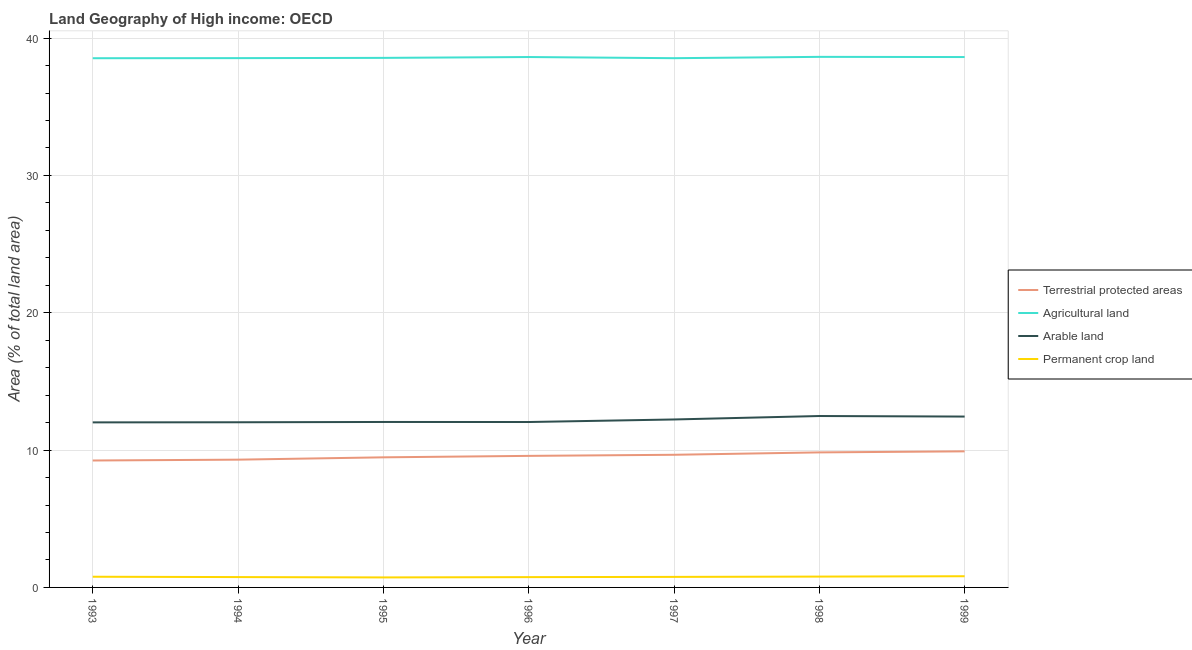How many different coloured lines are there?
Provide a succinct answer. 4. What is the percentage of area under arable land in 1993?
Your answer should be compact. 12.02. Across all years, what is the maximum percentage of area under permanent crop land?
Ensure brevity in your answer.  0.81. Across all years, what is the minimum percentage of area under arable land?
Provide a short and direct response. 12.02. In which year was the percentage of area under arable land maximum?
Provide a succinct answer. 1998. In which year was the percentage of area under arable land minimum?
Ensure brevity in your answer.  1993. What is the total percentage of land under terrestrial protection in the graph?
Provide a short and direct response. 67. What is the difference between the percentage of area under permanent crop land in 1993 and that in 1995?
Keep it short and to the point. 0.05. What is the difference between the percentage of area under arable land in 1998 and the percentage of land under terrestrial protection in 1995?
Ensure brevity in your answer.  3.01. What is the average percentage of area under permanent crop land per year?
Offer a very short reply. 0.77. In the year 1998, what is the difference between the percentage of area under arable land and percentage of land under terrestrial protection?
Offer a very short reply. 2.65. In how many years, is the percentage of land under terrestrial protection greater than 28 %?
Offer a very short reply. 0. What is the ratio of the percentage of area under arable land in 1997 to that in 1998?
Offer a very short reply. 0.98. Is the difference between the percentage of area under permanent crop land in 1994 and 1995 greater than the difference between the percentage of land under terrestrial protection in 1994 and 1995?
Make the answer very short. Yes. What is the difference between the highest and the second highest percentage of area under agricultural land?
Ensure brevity in your answer.  0.01. What is the difference between the highest and the lowest percentage of land under terrestrial protection?
Offer a very short reply. 0.67. In how many years, is the percentage of area under permanent crop land greater than the average percentage of area under permanent crop land taken over all years?
Offer a terse response. 3. Is it the case that in every year, the sum of the percentage of land under terrestrial protection and percentage of area under arable land is greater than the sum of percentage of area under permanent crop land and percentage of area under agricultural land?
Offer a terse response. Yes. Is it the case that in every year, the sum of the percentage of land under terrestrial protection and percentage of area under agricultural land is greater than the percentage of area under arable land?
Give a very brief answer. Yes. Does the percentage of area under agricultural land monotonically increase over the years?
Your answer should be very brief. No. How many lines are there?
Offer a terse response. 4. How many years are there in the graph?
Provide a short and direct response. 7. Are the values on the major ticks of Y-axis written in scientific E-notation?
Keep it short and to the point. No. Does the graph contain grids?
Make the answer very short. Yes. Where does the legend appear in the graph?
Provide a short and direct response. Center right. What is the title of the graph?
Give a very brief answer. Land Geography of High income: OECD. What is the label or title of the Y-axis?
Your answer should be very brief. Area (% of total land area). What is the Area (% of total land area) in Terrestrial protected areas in 1993?
Your response must be concise. 9.24. What is the Area (% of total land area) in Agricultural land in 1993?
Offer a very short reply. 38.53. What is the Area (% of total land area) of Arable land in 1993?
Make the answer very short. 12.02. What is the Area (% of total land area) of Permanent crop land in 1993?
Your response must be concise. 0.78. What is the Area (% of total land area) in Terrestrial protected areas in 1994?
Your answer should be very brief. 9.3. What is the Area (% of total land area) in Agricultural land in 1994?
Offer a terse response. 38.54. What is the Area (% of total land area) in Arable land in 1994?
Give a very brief answer. 12.03. What is the Area (% of total land area) of Permanent crop land in 1994?
Make the answer very short. 0.75. What is the Area (% of total land area) in Terrestrial protected areas in 1995?
Your response must be concise. 9.47. What is the Area (% of total land area) in Agricultural land in 1995?
Offer a very short reply. 38.56. What is the Area (% of total land area) in Arable land in 1995?
Ensure brevity in your answer.  12.05. What is the Area (% of total land area) in Permanent crop land in 1995?
Keep it short and to the point. 0.73. What is the Area (% of total land area) of Terrestrial protected areas in 1996?
Ensure brevity in your answer.  9.58. What is the Area (% of total land area) of Agricultural land in 1996?
Your answer should be very brief. 38.62. What is the Area (% of total land area) in Arable land in 1996?
Provide a succinct answer. 12.04. What is the Area (% of total land area) of Permanent crop land in 1996?
Give a very brief answer. 0.75. What is the Area (% of total land area) in Terrestrial protected areas in 1997?
Ensure brevity in your answer.  9.66. What is the Area (% of total land area) in Agricultural land in 1997?
Make the answer very short. 38.54. What is the Area (% of total land area) in Arable land in 1997?
Offer a very short reply. 12.23. What is the Area (% of total land area) of Permanent crop land in 1997?
Make the answer very short. 0.77. What is the Area (% of total land area) of Terrestrial protected areas in 1998?
Your answer should be very brief. 9.83. What is the Area (% of total land area) in Agricultural land in 1998?
Ensure brevity in your answer.  38.63. What is the Area (% of total land area) in Arable land in 1998?
Your answer should be compact. 12.48. What is the Area (% of total land area) of Permanent crop land in 1998?
Your answer should be compact. 0.79. What is the Area (% of total land area) of Terrestrial protected areas in 1999?
Ensure brevity in your answer.  9.91. What is the Area (% of total land area) of Agricultural land in 1999?
Keep it short and to the point. 38.62. What is the Area (% of total land area) in Arable land in 1999?
Give a very brief answer. 12.44. What is the Area (% of total land area) in Permanent crop land in 1999?
Your response must be concise. 0.81. Across all years, what is the maximum Area (% of total land area) of Terrestrial protected areas?
Give a very brief answer. 9.91. Across all years, what is the maximum Area (% of total land area) of Agricultural land?
Provide a short and direct response. 38.63. Across all years, what is the maximum Area (% of total land area) of Arable land?
Offer a terse response. 12.48. Across all years, what is the maximum Area (% of total land area) in Permanent crop land?
Offer a very short reply. 0.81. Across all years, what is the minimum Area (% of total land area) in Terrestrial protected areas?
Your answer should be very brief. 9.24. Across all years, what is the minimum Area (% of total land area) of Agricultural land?
Give a very brief answer. 38.53. Across all years, what is the minimum Area (% of total land area) of Arable land?
Keep it short and to the point. 12.02. Across all years, what is the minimum Area (% of total land area) of Permanent crop land?
Offer a terse response. 0.73. What is the total Area (% of total land area) of Terrestrial protected areas in the graph?
Give a very brief answer. 67. What is the total Area (% of total land area) of Agricultural land in the graph?
Offer a terse response. 270.04. What is the total Area (% of total land area) of Arable land in the graph?
Ensure brevity in your answer.  85.29. What is the total Area (% of total land area) in Permanent crop land in the graph?
Offer a very short reply. 5.38. What is the difference between the Area (% of total land area) in Terrestrial protected areas in 1993 and that in 1994?
Your answer should be very brief. -0.06. What is the difference between the Area (% of total land area) of Agricultural land in 1993 and that in 1994?
Your answer should be compact. -0.01. What is the difference between the Area (% of total land area) in Arable land in 1993 and that in 1994?
Offer a terse response. -0.01. What is the difference between the Area (% of total land area) of Permanent crop land in 1993 and that in 1994?
Provide a short and direct response. 0.03. What is the difference between the Area (% of total land area) in Terrestrial protected areas in 1993 and that in 1995?
Your answer should be compact. -0.23. What is the difference between the Area (% of total land area) of Agricultural land in 1993 and that in 1995?
Make the answer very short. -0.02. What is the difference between the Area (% of total land area) of Arable land in 1993 and that in 1995?
Your answer should be very brief. -0.03. What is the difference between the Area (% of total land area) of Permanent crop land in 1993 and that in 1995?
Offer a very short reply. 0.05. What is the difference between the Area (% of total land area) of Terrestrial protected areas in 1993 and that in 1996?
Give a very brief answer. -0.34. What is the difference between the Area (% of total land area) in Agricultural land in 1993 and that in 1996?
Your response must be concise. -0.09. What is the difference between the Area (% of total land area) in Arable land in 1993 and that in 1996?
Give a very brief answer. -0.03. What is the difference between the Area (% of total land area) of Permanent crop land in 1993 and that in 1996?
Offer a very short reply. 0.03. What is the difference between the Area (% of total land area) of Terrestrial protected areas in 1993 and that in 1997?
Offer a terse response. -0.42. What is the difference between the Area (% of total land area) of Agricultural land in 1993 and that in 1997?
Provide a short and direct response. -0. What is the difference between the Area (% of total land area) in Arable land in 1993 and that in 1997?
Keep it short and to the point. -0.21. What is the difference between the Area (% of total land area) in Permanent crop land in 1993 and that in 1997?
Ensure brevity in your answer.  0.01. What is the difference between the Area (% of total land area) of Terrestrial protected areas in 1993 and that in 1998?
Provide a succinct answer. -0.59. What is the difference between the Area (% of total land area) in Agricultural land in 1993 and that in 1998?
Your answer should be compact. -0.1. What is the difference between the Area (% of total land area) in Arable land in 1993 and that in 1998?
Provide a short and direct response. -0.46. What is the difference between the Area (% of total land area) in Permanent crop land in 1993 and that in 1998?
Provide a short and direct response. -0.01. What is the difference between the Area (% of total land area) in Terrestrial protected areas in 1993 and that in 1999?
Ensure brevity in your answer.  -0.67. What is the difference between the Area (% of total land area) in Agricultural land in 1993 and that in 1999?
Make the answer very short. -0.08. What is the difference between the Area (% of total land area) in Arable land in 1993 and that in 1999?
Give a very brief answer. -0.42. What is the difference between the Area (% of total land area) in Permanent crop land in 1993 and that in 1999?
Provide a short and direct response. -0.04. What is the difference between the Area (% of total land area) in Terrestrial protected areas in 1994 and that in 1995?
Your answer should be compact. -0.17. What is the difference between the Area (% of total land area) in Agricultural land in 1994 and that in 1995?
Your response must be concise. -0.02. What is the difference between the Area (% of total land area) of Arable land in 1994 and that in 1995?
Provide a short and direct response. -0.02. What is the difference between the Area (% of total land area) of Permanent crop land in 1994 and that in 1995?
Offer a very short reply. 0.02. What is the difference between the Area (% of total land area) in Terrestrial protected areas in 1994 and that in 1996?
Your answer should be very brief. -0.28. What is the difference between the Area (% of total land area) of Agricultural land in 1994 and that in 1996?
Offer a very short reply. -0.08. What is the difference between the Area (% of total land area) in Arable land in 1994 and that in 1996?
Give a very brief answer. -0.02. What is the difference between the Area (% of total land area) of Permanent crop land in 1994 and that in 1996?
Offer a terse response. 0. What is the difference between the Area (% of total land area) in Terrestrial protected areas in 1994 and that in 1997?
Your answer should be very brief. -0.36. What is the difference between the Area (% of total land area) in Agricultural land in 1994 and that in 1997?
Offer a terse response. 0.01. What is the difference between the Area (% of total land area) in Arable land in 1994 and that in 1997?
Ensure brevity in your answer.  -0.2. What is the difference between the Area (% of total land area) in Permanent crop land in 1994 and that in 1997?
Your response must be concise. -0.01. What is the difference between the Area (% of total land area) of Terrestrial protected areas in 1994 and that in 1998?
Ensure brevity in your answer.  -0.53. What is the difference between the Area (% of total land area) in Agricultural land in 1994 and that in 1998?
Ensure brevity in your answer.  -0.09. What is the difference between the Area (% of total land area) of Arable land in 1994 and that in 1998?
Offer a terse response. -0.46. What is the difference between the Area (% of total land area) in Permanent crop land in 1994 and that in 1998?
Your answer should be very brief. -0.04. What is the difference between the Area (% of total land area) in Terrestrial protected areas in 1994 and that in 1999?
Keep it short and to the point. -0.6. What is the difference between the Area (% of total land area) in Agricultural land in 1994 and that in 1999?
Ensure brevity in your answer.  -0.08. What is the difference between the Area (% of total land area) of Arable land in 1994 and that in 1999?
Give a very brief answer. -0.41. What is the difference between the Area (% of total land area) of Permanent crop land in 1994 and that in 1999?
Provide a short and direct response. -0.06. What is the difference between the Area (% of total land area) of Terrestrial protected areas in 1995 and that in 1996?
Your answer should be compact. -0.11. What is the difference between the Area (% of total land area) in Agricultural land in 1995 and that in 1996?
Keep it short and to the point. -0.06. What is the difference between the Area (% of total land area) of Arable land in 1995 and that in 1996?
Keep it short and to the point. 0. What is the difference between the Area (% of total land area) of Permanent crop land in 1995 and that in 1996?
Provide a short and direct response. -0.02. What is the difference between the Area (% of total land area) in Terrestrial protected areas in 1995 and that in 1997?
Offer a very short reply. -0.19. What is the difference between the Area (% of total land area) in Agricultural land in 1995 and that in 1997?
Ensure brevity in your answer.  0.02. What is the difference between the Area (% of total land area) in Arable land in 1995 and that in 1997?
Offer a very short reply. -0.18. What is the difference between the Area (% of total land area) in Permanent crop land in 1995 and that in 1997?
Keep it short and to the point. -0.04. What is the difference between the Area (% of total land area) in Terrestrial protected areas in 1995 and that in 1998?
Your answer should be very brief. -0.36. What is the difference between the Area (% of total land area) in Agricultural land in 1995 and that in 1998?
Your answer should be very brief. -0.07. What is the difference between the Area (% of total land area) in Arable land in 1995 and that in 1998?
Your answer should be very brief. -0.43. What is the difference between the Area (% of total land area) in Permanent crop land in 1995 and that in 1998?
Your answer should be very brief. -0.06. What is the difference between the Area (% of total land area) in Terrestrial protected areas in 1995 and that in 1999?
Your response must be concise. -0.44. What is the difference between the Area (% of total land area) of Agricultural land in 1995 and that in 1999?
Provide a succinct answer. -0.06. What is the difference between the Area (% of total land area) of Arable land in 1995 and that in 1999?
Offer a very short reply. -0.39. What is the difference between the Area (% of total land area) of Permanent crop land in 1995 and that in 1999?
Provide a succinct answer. -0.09. What is the difference between the Area (% of total land area) of Terrestrial protected areas in 1996 and that in 1997?
Your answer should be very brief. -0.08. What is the difference between the Area (% of total land area) of Agricultural land in 1996 and that in 1997?
Ensure brevity in your answer.  0.08. What is the difference between the Area (% of total land area) in Arable land in 1996 and that in 1997?
Provide a succinct answer. -0.19. What is the difference between the Area (% of total land area) in Permanent crop land in 1996 and that in 1997?
Your answer should be compact. -0.02. What is the difference between the Area (% of total land area) in Terrestrial protected areas in 1996 and that in 1998?
Give a very brief answer. -0.25. What is the difference between the Area (% of total land area) in Agricultural land in 1996 and that in 1998?
Make the answer very short. -0.01. What is the difference between the Area (% of total land area) of Arable land in 1996 and that in 1998?
Provide a succinct answer. -0.44. What is the difference between the Area (% of total land area) of Permanent crop land in 1996 and that in 1998?
Ensure brevity in your answer.  -0.04. What is the difference between the Area (% of total land area) in Terrestrial protected areas in 1996 and that in 1999?
Your response must be concise. -0.33. What is the difference between the Area (% of total land area) in Agricultural land in 1996 and that in 1999?
Provide a succinct answer. 0. What is the difference between the Area (% of total land area) of Arable land in 1996 and that in 1999?
Provide a short and direct response. -0.4. What is the difference between the Area (% of total land area) of Permanent crop land in 1996 and that in 1999?
Provide a short and direct response. -0.06. What is the difference between the Area (% of total land area) of Terrestrial protected areas in 1997 and that in 1998?
Offer a terse response. -0.17. What is the difference between the Area (% of total land area) in Agricultural land in 1997 and that in 1998?
Your answer should be very brief. -0.1. What is the difference between the Area (% of total land area) in Arable land in 1997 and that in 1998?
Your answer should be compact. -0.25. What is the difference between the Area (% of total land area) in Permanent crop land in 1997 and that in 1998?
Provide a short and direct response. -0.02. What is the difference between the Area (% of total land area) of Terrestrial protected areas in 1997 and that in 1999?
Ensure brevity in your answer.  -0.25. What is the difference between the Area (% of total land area) in Agricultural land in 1997 and that in 1999?
Provide a succinct answer. -0.08. What is the difference between the Area (% of total land area) in Arable land in 1997 and that in 1999?
Make the answer very short. -0.21. What is the difference between the Area (% of total land area) of Permanent crop land in 1997 and that in 1999?
Provide a short and direct response. -0.05. What is the difference between the Area (% of total land area) of Terrestrial protected areas in 1998 and that in 1999?
Keep it short and to the point. -0.08. What is the difference between the Area (% of total land area) in Agricultural land in 1998 and that in 1999?
Offer a very short reply. 0.01. What is the difference between the Area (% of total land area) in Arable land in 1998 and that in 1999?
Your answer should be compact. 0.04. What is the difference between the Area (% of total land area) in Permanent crop land in 1998 and that in 1999?
Provide a succinct answer. -0.03. What is the difference between the Area (% of total land area) of Terrestrial protected areas in 1993 and the Area (% of total land area) of Agricultural land in 1994?
Provide a succinct answer. -29.3. What is the difference between the Area (% of total land area) of Terrestrial protected areas in 1993 and the Area (% of total land area) of Arable land in 1994?
Ensure brevity in your answer.  -2.78. What is the difference between the Area (% of total land area) of Terrestrial protected areas in 1993 and the Area (% of total land area) of Permanent crop land in 1994?
Make the answer very short. 8.49. What is the difference between the Area (% of total land area) of Agricultural land in 1993 and the Area (% of total land area) of Arable land in 1994?
Your response must be concise. 26.51. What is the difference between the Area (% of total land area) in Agricultural land in 1993 and the Area (% of total land area) in Permanent crop land in 1994?
Your answer should be compact. 37.78. What is the difference between the Area (% of total land area) of Arable land in 1993 and the Area (% of total land area) of Permanent crop land in 1994?
Provide a succinct answer. 11.26. What is the difference between the Area (% of total land area) of Terrestrial protected areas in 1993 and the Area (% of total land area) of Agricultural land in 1995?
Your answer should be compact. -29.32. What is the difference between the Area (% of total land area) in Terrestrial protected areas in 1993 and the Area (% of total land area) in Arable land in 1995?
Your answer should be compact. -2.81. What is the difference between the Area (% of total land area) in Terrestrial protected areas in 1993 and the Area (% of total land area) in Permanent crop land in 1995?
Your answer should be very brief. 8.51. What is the difference between the Area (% of total land area) of Agricultural land in 1993 and the Area (% of total land area) of Arable land in 1995?
Your response must be concise. 26.49. What is the difference between the Area (% of total land area) of Agricultural land in 1993 and the Area (% of total land area) of Permanent crop land in 1995?
Your answer should be compact. 37.81. What is the difference between the Area (% of total land area) of Arable land in 1993 and the Area (% of total land area) of Permanent crop land in 1995?
Offer a terse response. 11.29. What is the difference between the Area (% of total land area) in Terrestrial protected areas in 1993 and the Area (% of total land area) in Agricultural land in 1996?
Ensure brevity in your answer.  -29.38. What is the difference between the Area (% of total land area) of Terrestrial protected areas in 1993 and the Area (% of total land area) of Arable land in 1996?
Offer a very short reply. -2.8. What is the difference between the Area (% of total land area) in Terrestrial protected areas in 1993 and the Area (% of total land area) in Permanent crop land in 1996?
Offer a very short reply. 8.49. What is the difference between the Area (% of total land area) of Agricultural land in 1993 and the Area (% of total land area) of Arable land in 1996?
Give a very brief answer. 26.49. What is the difference between the Area (% of total land area) of Agricultural land in 1993 and the Area (% of total land area) of Permanent crop land in 1996?
Give a very brief answer. 37.78. What is the difference between the Area (% of total land area) in Arable land in 1993 and the Area (% of total land area) in Permanent crop land in 1996?
Give a very brief answer. 11.27. What is the difference between the Area (% of total land area) of Terrestrial protected areas in 1993 and the Area (% of total land area) of Agricultural land in 1997?
Give a very brief answer. -29.29. What is the difference between the Area (% of total land area) of Terrestrial protected areas in 1993 and the Area (% of total land area) of Arable land in 1997?
Give a very brief answer. -2.99. What is the difference between the Area (% of total land area) in Terrestrial protected areas in 1993 and the Area (% of total land area) in Permanent crop land in 1997?
Give a very brief answer. 8.47. What is the difference between the Area (% of total land area) of Agricultural land in 1993 and the Area (% of total land area) of Arable land in 1997?
Your answer should be compact. 26.3. What is the difference between the Area (% of total land area) of Agricultural land in 1993 and the Area (% of total land area) of Permanent crop land in 1997?
Ensure brevity in your answer.  37.77. What is the difference between the Area (% of total land area) in Arable land in 1993 and the Area (% of total land area) in Permanent crop land in 1997?
Provide a succinct answer. 11.25. What is the difference between the Area (% of total land area) in Terrestrial protected areas in 1993 and the Area (% of total land area) in Agricultural land in 1998?
Keep it short and to the point. -29.39. What is the difference between the Area (% of total land area) in Terrestrial protected areas in 1993 and the Area (% of total land area) in Arable land in 1998?
Ensure brevity in your answer.  -3.24. What is the difference between the Area (% of total land area) of Terrestrial protected areas in 1993 and the Area (% of total land area) of Permanent crop land in 1998?
Offer a terse response. 8.45. What is the difference between the Area (% of total land area) in Agricultural land in 1993 and the Area (% of total land area) in Arable land in 1998?
Give a very brief answer. 26.05. What is the difference between the Area (% of total land area) in Agricultural land in 1993 and the Area (% of total land area) in Permanent crop land in 1998?
Provide a short and direct response. 37.75. What is the difference between the Area (% of total land area) in Arable land in 1993 and the Area (% of total land area) in Permanent crop land in 1998?
Your answer should be compact. 11.23. What is the difference between the Area (% of total land area) of Terrestrial protected areas in 1993 and the Area (% of total land area) of Agricultural land in 1999?
Offer a terse response. -29.38. What is the difference between the Area (% of total land area) of Terrestrial protected areas in 1993 and the Area (% of total land area) of Arable land in 1999?
Provide a succinct answer. -3.2. What is the difference between the Area (% of total land area) of Terrestrial protected areas in 1993 and the Area (% of total land area) of Permanent crop land in 1999?
Give a very brief answer. 8.43. What is the difference between the Area (% of total land area) in Agricultural land in 1993 and the Area (% of total land area) in Arable land in 1999?
Ensure brevity in your answer.  26.09. What is the difference between the Area (% of total land area) of Agricultural land in 1993 and the Area (% of total land area) of Permanent crop land in 1999?
Keep it short and to the point. 37.72. What is the difference between the Area (% of total land area) in Arable land in 1993 and the Area (% of total land area) in Permanent crop land in 1999?
Provide a short and direct response. 11.2. What is the difference between the Area (% of total land area) in Terrestrial protected areas in 1994 and the Area (% of total land area) in Agricultural land in 1995?
Provide a short and direct response. -29.26. What is the difference between the Area (% of total land area) in Terrestrial protected areas in 1994 and the Area (% of total land area) in Arable land in 1995?
Offer a very short reply. -2.74. What is the difference between the Area (% of total land area) in Terrestrial protected areas in 1994 and the Area (% of total land area) in Permanent crop land in 1995?
Keep it short and to the point. 8.57. What is the difference between the Area (% of total land area) of Agricultural land in 1994 and the Area (% of total land area) of Arable land in 1995?
Ensure brevity in your answer.  26.49. What is the difference between the Area (% of total land area) of Agricultural land in 1994 and the Area (% of total land area) of Permanent crop land in 1995?
Your response must be concise. 37.81. What is the difference between the Area (% of total land area) of Arable land in 1994 and the Area (% of total land area) of Permanent crop land in 1995?
Provide a succinct answer. 11.3. What is the difference between the Area (% of total land area) of Terrestrial protected areas in 1994 and the Area (% of total land area) of Agricultural land in 1996?
Ensure brevity in your answer.  -29.32. What is the difference between the Area (% of total land area) of Terrestrial protected areas in 1994 and the Area (% of total land area) of Arable land in 1996?
Keep it short and to the point. -2.74. What is the difference between the Area (% of total land area) of Terrestrial protected areas in 1994 and the Area (% of total land area) of Permanent crop land in 1996?
Your response must be concise. 8.55. What is the difference between the Area (% of total land area) in Agricultural land in 1994 and the Area (% of total land area) in Arable land in 1996?
Your response must be concise. 26.5. What is the difference between the Area (% of total land area) of Agricultural land in 1994 and the Area (% of total land area) of Permanent crop land in 1996?
Offer a terse response. 37.79. What is the difference between the Area (% of total land area) of Arable land in 1994 and the Area (% of total land area) of Permanent crop land in 1996?
Your answer should be compact. 11.28. What is the difference between the Area (% of total land area) in Terrestrial protected areas in 1994 and the Area (% of total land area) in Agricultural land in 1997?
Your response must be concise. -29.23. What is the difference between the Area (% of total land area) in Terrestrial protected areas in 1994 and the Area (% of total land area) in Arable land in 1997?
Give a very brief answer. -2.93. What is the difference between the Area (% of total land area) of Terrestrial protected areas in 1994 and the Area (% of total land area) of Permanent crop land in 1997?
Offer a very short reply. 8.54. What is the difference between the Area (% of total land area) of Agricultural land in 1994 and the Area (% of total land area) of Arable land in 1997?
Ensure brevity in your answer.  26.31. What is the difference between the Area (% of total land area) in Agricultural land in 1994 and the Area (% of total land area) in Permanent crop land in 1997?
Provide a short and direct response. 37.77. What is the difference between the Area (% of total land area) of Arable land in 1994 and the Area (% of total land area) of Permanent crop land in 1997?
Make the answer very short. 11.26. What is the difference between the Area (% of total land area) of Terrestrial protected areas in 1994 and the Area (% of total land area) of Agricultural land in 1998?
Give a very brief answer. -29.33. What is the difference between the Area (% of total land area) in Terrestrial protected areas in 1994 and the Area (% of total land area) in Arable land in 1998?
Offer a terse response. -3.18. What is the difference between the Area (% of total land area) in Terrestrial protected areas in 1994 and the Area (% of total land area) in Permanent crop land in 1998?
Keep it short and to the point. 8.51. What is the difference between the Area (% of total land area) of Agricultural land in 1994 and the Area (% of total land area) of Arable land in 1998?
Provide a succinct answer. 26.06. What is the difference between the Area (% of total land area) of Agricultural land in 1994 and the Area (% of total land area) of Permanent crop land in 1998?
Keep it short and to the point. 37.75. What is the difference between the Area (% of total land area) of Arable land in 1994 and the Area (% of total land area) of Permanent crop land in 1998?
Ensure brevity in your answer.  11.24. What is the difference between the Area (% of total land area) in Terrestrial protected areas in 1994 and the Area (% of total land area) in Agricultural land in 1999?
Ensure brevity in your answer.  -29.32. What is the difference between the Area (% of total land area) of Terrestrial protected areas in 1994 and the Area (% of total land area) of Arable land in 1999?
Provide a succinct answer. -3.14. What is the difference between the Area (% of total land area) of Terrestrial protected areas in 1994 and the Area (% of total land area) of Permanent crop land in 1999?
Give a very brief answer. 8.49. What is the difference between the Area (% of total land area) in Agricultural land in 1994 and the Area (% of total land area) in Arable land in 1999?
Provide a short and direct response. 26.1. What is the difference between the Area (% of total land area) in Agricultural land in 1994 and the Area (% of total land area) in Permanent crop land in 1999?
Your answer should be compact. 37.73. What is the difference between the Area (% of total land area) in Arable land in 1994 and the Area (% of total land area) in Permanent crop land in 1999?
Ensure brevity in your answer.  11.21. What is the difference between the Area (% of total land area) of Terrestrial protected areas in 1995 and the Area (% of total land area) of Agricultural land in 1996?
Offer a terse response. -29.15. What is the difference between the Area (% of total land area) of Terrestrial protected areas in 1995 and the Area (% of total land area) of Arable land in 1996?
Make the answer very short. -2.57. What is the difference between the Area (% of total land area) of Terrestrial protected areas in 1995 and the Area (% of total land area) of Permanent crop land in 1996?
Your answer should be very brief. 8.72. What is the difference between the Area (% of total land area) in Agricultural land in 1995 and the Area (% of total land area) in Arable land in 1996?
Give a very brief answer. 26.51. What is the difference between the Area (% of total land area) in Agricultural land in 1995 and the Area (% of total land area) in Permanent crop land in 1996?
Provide a short and direct response. 37.81. What is the difference between the Area (% of total land area) of Arable land in 1995 and the Area (% of total land area) of Permanent crop land in 1996?
Offer a terse response. 11.3. What is the difference between the Area (% of total land area) of Terrestrial protected areas in 1995 and the Area (% of total land area) of Agricultural land in 1997?
Ensure brevity in your answer.  -29.06. What is the difference between the Area (% of total land area) in Terrestrial protected areas in 1995 and the Area (% of total land area) in Arable land in 1997?
Keep it short and to the point. -2.76. What is the difference between the Area (% of total land area) of Terrestrial protected areas in 1995 and the Area (% of total land area) of Permanent crop land in 1997?
Offer a very short reply. 8.71. What is the difference between the Area (% of total land area) of Agricultural land in 1995 and the Area (% of total land area) of Arable land in 1997?
Make the answer very short. 26.33. What is the difference between the Area (% of total land area) of Agricultural land in 1995 and the Area (% of total land area) of Permanent crop land in 1997?
Your answer should be compact. 37.79. What is the difference between the Area (% of total land area) in Arable land in 1995 and the Area (% of total land area) in Permanent crop land in 1997?
Your answer should be compact. 11.28. What is the difference between the Area (% of total land area) in Terrestrial protected areas in 1995 and the Area (% of total land area) in Agricultural land in 1998?
Ensure brevity in your answer.  -29.16. What is the difference between the Area (% of total land area) of Terrestrial protected areas in 1995 and the Area (% of total land area) of Arable land in 1998?
Your response must be concise. -3.01. What is the difference between the Area (% of total land area) of Terrestrial protected areas in 1995 and the Area (% of total land area) of Permanent crop land in 1998?
Your answer should be very brief. 8.68. What is the difference between the Area (% of total land area) of Agricultural land in 1995 and the Area (% of total land area) of Arable land in 1998?
Ensure brevity in your answer.  26.08. What is the difference between the Area (% of total land area) of Agricultural land in 1995 and the Area (% of total land area) of Permanent crop land in 1998?
Give a very brief answer. 37.77. What is the difference between the Area (% of total land area) of Arable land in 1995 and the Area (% of total land area) of Permanent crop land in 1998?
Provide a succinct answer. 11.26. What is the difference between the Area (% of total land area) in Terrestrial protected areas in 1995 and the Area (% of total land area) in Agricultural land in 1999?
Give a very brief answer. -29.15. What is the difference between the Area (% of total land area) of Terrestrial protected areas in 1995 and the Area (% of total land area) of Arable land in 1999?
Your response must be concise. -2.97. What is the difference between the Area (% of total land area) in Terrestrial protected areas in 1995 and the Area (% of total land area) in Permanent crop land in 1999?
Provide a succinct answer. 8.66. What is the difference between the Area (% of total land area) in Agricultural land in 1995 and the Area (% of total land area) in Arable land in 1999?
Your answer should be very brief. 26.12. What is the difference between the Area (% of total land area) in Agricultural land in 1995 and the Area (% of total land area) in Permanent crop land in 1999?
Provide a succinct answer. 37.74. What is the difference between the Area (% of total land area) of Arable land in 1995 and the Area (% of total land area) of Permanent crop land in 1999?
Ensure brevity in your answer.  11.23. What is the difference between the Area (% of total land area) in Terrestrial protected areas in 1996 and the Area (% of total land area) in Agricultural land in 1997?
Make the answer very short. -28.96. What is the difference between the Area (% of total land area) in Terrestrial protected areas in 1996 and the Area (% of total land area) in Arable land in 1997?
Give a very brief answer. -2.65. What is the difference between the Area (% of total land area) of Terrestrial protected areas in 1996 and the Area (% of total land area) of Permanent crop land in 1997?
Make the answer very short. 8.81. What is the difference between the Area (% of total land area) in Agricultural land in 1996 and the Area (% of total land area) in Arable land in 1997?
Your answer should be compact. 26.39. What is the difference between the Area (% of total land area) of Agricultural land in 1996 and the Area (% of total land area) of Permanent crop land in 1997?
Offer a terse response. 37.85. What is the difference between the Area (% of total land area) of Arable land in 1996 and the Area (% of total land area) of Permanent crop land in 1997?
Ensure brevity in your answer.  11.28. What is the difference between the Area (% of total land area) in Terrestrial protected areas in 1996 and the Area (% of total land area) in Agricultural land in 1998?
Your answer should be compact. -29.05. What is the difference between the Area (% of total land area) of Terrestrial protected areas in 1996 and the Area (% of total land area) of Arable land in 1998?
Your answer should be very brief. -2.9. What is the difference between the Area (% of total land area) in Terrestrial protected areas in 1996 and the Area (% of total land area) in Permanent crop land in 1998?
Make the answer very short. 8.79. What is the difference between the Area (% of total land area) of Agricultural land in 1996 and the Area (% of total land area) of Arable land in 1998?
Ensure brevity in your answer.  26.14. What is the difference between the Area (% of total land area) in Agricultural land in 1996 and the Area (% of total land area) in Permanent crop land in 1998?
Give a very brief answer. 37.83. What is the difference between the Area (% of total land area) of Arable land in 1996 and the Area (% of total land area) of Permanent crop land in 1998?
Provide a short and direct response. 11.26. What is the difference between the Area (% of total land area) in Terrestrial protected areas in 1996 and the Area (% of total land area) in Agricultural land in 1999?
Provide a succinct answer. -29.04. What is the difference between the Area (% of total land area) in Terrestrial protected areas in 1996 and the Area (% of total land area) in Arable land in 1999?
Offer a very short reply. -2.86. What is the difference between the Area (% of total land area) of Terrestrial protected areas in 1996 and the Area (% of total land area) of Permanent crop land in 1999?
Your response must be concise. 8.76. What is the difference between the Area (% of total land area) of Agricultural land in 1996 and the Area (% of total land area) of Arable land in 1999?
Your answer should be very brief. 26.18. What is the difference between the Area (% of total land area) in Agricultural land in 1996 and the Area (% of total land area) in Permanent crop land in 1999?
Ensure brevity in your answer.  37.81. What is the difference between the Area (% of total land area) of Arable land in 1996 and the Area (% of total land area) of Permanent crop land in 1999?
Give a very brief answer. 11.23. What is the difference between the Area (% of total land area) in Terrestrial protected areas in 1997 and the Area (% of total land area) in Agricultural land in 1998?
Make the answer very short. -28.97. What is the difference between the Area (% of total land area) of Terrestrial protected areas in 1997 and the Area (% of total land area) of Arable land in 1998?
Keep it short and to the point. -2.82. What is the difference between the Area (% of total land area) in Terrestrial protected areas in 1997 and the Area (% of total land area) in Permanent crop land in 1998?
Keep it short and to the point. 8.87. What is the difference between the Area (% of total land area) of Agricultural land in 1997 and the Area (% of total land area) of Arable land in 1998?
Provide a succinct answer. 26.05. What is the difference between the Area (% of total land area) in Agricultural land in 1997 and the Area (% of total land area) in Permanent crop land in 1998?
Keep it short and to the point. 37.75. What is the difference between the Area (% of total land area) in Arable land in 1997 and the Area (% of total land area) in Permanent crop land in 1998?
Your answer should be very brief. 11.44. What is the difference between the Area (% of total land area) in Terrestrial protected areas in 1997 and the Area (% of total land area) in Agricultural land in 1999?
Give a very brief answer. -28.96. What is the difference between the Area (% of total land area) of Terrestrial protected areas in 1997 and the Area (% of total land area) of Arable land in 1999?
Offer a terse response. -2.78. What is the difference between the Area (% of total land area) in Terrestrial protected areas in 1997 and the Area (% of total land area) in Permanent crop land in 1999?
Offer a terse response. 8.84. What is the difference between the Area (% of total land area) in Agricultural land in 1997 and the Area (% of total land area) in Arable land in 1999?
Offer a terse response. 26.1. What is the difference between the Area (% of total land area) of Agricultural land in 1997 and the Area (% of total land area) of Permanent crop land in 1999?
Offer a terse response. 37.72. What is the difference between the Area (% of total land area) of Arable land in 1997 and the Area (% of total land area) of Permanent crop land in 1999?
Make the answer very short. 11.42. What is the difference between the Area (% of total land area) of Terrestrial protected areas in 1998 and the Area (% of total land area) of Agricultural land in 1999?
Ensure brevity in your answer.  -28.79. What is the difference between the Area (% of total land area) of Terrestrial protected areas in 1998 and the Area (% of total land area) of Arable land in 1999?
Provide a succinct answer. -2.61. What is the difference between the Area (% of total land area) in Terrestrial protected areas in 1998 and the Area (% of total land area) in Permanent crop land in 1999?
Your answer should be very brief. 9.02. What is the difference between the Area (% of total land area) of Agricultural land in 1998 and the Area (% of total land area) of Arable land in 1999?
Offer a terse response. 26.19. What is the difference between the Area (% of total land area) in Agricultural land in 1998 and the Area (% of total land area) in Permanent crop land in 1999?
Make the answer very short. 37.82. What is the difference between the Area (% of total land area) of Arable land in 1998 and the Area (% of total land area) of Permanent crop land in 1999?
Offer a very short reply. 11.67. What is the average Area (% of total land area) in Terrestrial protected areas per year?
Provide a short and direct response. 9.57. What is the average Area (% of total land area) of Agricultural land per year?
Make the answer very short. 38.58. What is the average Area (% of total land area) in Arable land per year?
Make the answer very short. 12.18. What is the average Area (% of total land area) of Permanent crop land per year?
Make the answer very short. 0.77. In the year 1993, what is the difference between the Area (% of total land area) in Terrestrial protected areas and Area (% of total land area) in Agricultural land?
Make the answer very short. -29.29. In the year 1993, what is the difference between the Area (% of total land area) in Terrestrial protected areas and Area (% of total land area) in Arable land?
Provide a succinct answer. -2.78. In the year 1993, what is the difference between the Area (% of total land area) of Terrestrial protected areas and Area (% of total land area) of Permanent crop land?
Provide a succinct answer. 8.46. In the year 1993, what is the difference between the Area (% of total land area) in Agricultural land and Area (% of total land area) in Arable land?
Provide a short and direct response. 26.52. In the year 1993, what is the difference between the Area (% of total land area) in Agricultural land and Area (% of total land area) in Permanent crop land?
Your answer should be compact. 37.76. In the year 1993, what is the difference between the Area (% of total land area) in Arable land and Area (% of total land area) in Permanent crop land?
Your response must be concise. 11.24. In the year 1994, what is the difference between the Area (% of total land area) in Terrestrial protected areas and Area (% of total land area) in Agricultural land?
Ensure brevity in your answer.  -29.24. In the year 1994, what is the difference between the Area (% of total land area) in Terrestrial protected areas and Area (% of total land area) in Arable land?
Offer a very short reply. -2.72. In the year 1994, what is the difference between the Area (% of total land area) of Terrestrial protected areas and Area (% of total land area) of Permanent crop land?
Provide a short and direct response. 8.55. In the year 1994, what is the difference between the Area (% of total land area) of Agricultural land and Area (% of total land area) of Arable land?
Provide a short and direct response. 26.51. In the year 1994, what is the difference between the Area (% of total land area) in Agricultural land and Area (% of total land area) in Permanent crop land?
Give a very brief answer. 37.79. In the year 1994, what is the difference between the Area (% of total land area) of Arable land and Area (% of total land area) of Permanent crop land?
Keep it short and to the point. 11.27. In the year 1995, what is the difference between the Area (% of total land area) in Terrestrial protected areas and Area (% of total land area) in Agricultural land?
Keep it short and to the point. -29.09. In the year 1995, what is the difference between the Area (% of total land area) of Terrestrial protected areas and Area (% of total land area) of Arable land?
Make the answer very short. -2.58. In the year 1995, what is the difference between the Area (% of total land area) in Terrestrial protected areas and Area (% of total land area) in Permanent crop land?
Your answer should be very brief. 8.74. In the year 1995, what is the difference between the Area (% of total land area) of Agricultural land and Area (% of total land area) of Arable land?
Provide a short and direct response. 26.51. In the year 1995, what is the difference between the Area (% of total land area) of Agricultural land and Area (% of total land area) of Permanent crop land?
Offer a very short reply. 37.83. In the year 1995, what is the difference between the Area (% of total land area) of Arable land and Area (% of total land area) of Permanent crop land?
Make the answer very short. 11.32. In the year 1996, what is the difference between the Area (% of total land area) in Terrestrial protected areas and Area (% of total land area) in Agricultural land?
Give a very brief answer. -29.04. In the year 1996, what is the difference between the Area (% of total land area) of Terrestrial protected areas and Area (% of total land area) of Arable land?
Keep it short and to the point. -2.47. In the year 1996, what is the difference between the Area (% of total land area) in Terrestrial protected areas and Area (% of total land area) in Permanent crop land?
Your answer should be compact. 8.83. In the year 1996, what is the difference between the Area (% of total land area) of Agricultural land and Area (% of total land area) of Arable land?
Give a very brief answer. 26.58. In the year 1996, what is the difference between the Area (% of total land area) of Agricultural land and Area (% of total land area) of Permanent crop land?
Your answer should be compact. 37.87. In the year 1996, what is the difference between the Area (% of total land area) of Arable land and Area (% of total land area) of Permanent crop land?
Your answer should be compact. 11.29. In the year 1997, what is the difference between the Area (% of total land area) of Terrestrial protected areas and Area (% of total land area) of Agricultural land?
Ensure brevity in your answer.  -28.88. In the year 1997, what is the difference between the Area (% of total land area) in Terrestrial protected areas and Area (% of total land area) in Arable land?
Offer a very short reply. -2.57. In the year 1997, what is the difference between the Area (% of total land area) in Terrestrial protected areas and Area (% of total land area) in Permanent crop land?
Your response must be concise. 8.89. In the year 1997, what is the difference between the Area (% of total land area) in Agricultural land and Area (% of total land area) in Arable land?
Offer a very short reply. 26.31. In the year 1997, what is the difference between the Area (% of total land area) in Agricultural land and Area (% of total land area) in Permanent crop land?
Offer a terse response. 37.77. In the year 1997, what is the difference between the Area (% of total land area) of Arable land and Area (% of total land area) of Permanent crop land?
Make the answer very short. 11.46. In the year 1998, what is the difference between the Area (% of total land area) of Terrestrial protected areas and Area (% of total land area) of Agricultural land?
Ensure brevity in your answer.  -28.8. In the year 1998, what is the difference between the Area (% of total land area) of Terrestrial protected areas and Area (% of total land area) of Arable land?
Ensure brevity in your answer.  -2.65. In the year 1998, what is the difference between the Area (% of total land area) of Terrestrial protected areas and Area (% of total land area) of Permanent crop land?
Your answer should be compact. 9.04. In the year 1998, what is the difference between the Area (% of total land area) of Agricultural land and Area (% of total land area) of Arable land?
Your response must be concise. 26.15. In the year 1998, what is the difference between the Area (% of total land area) in Agricultural land and Area (% of total land area) in Permanent crop land?
Make the answer very short. 37.84. In the year 1998, what is the difference between the Area (% of total land area) of Arable land and Area (% of total land area) of Permanent crop land?
Your response must be concise. 11.69. In the year 1999, what is the difference between the Area (% of total land area) in Terrestrial protected areas and Area (% of total land area) in Agricultural land?
Provide a short and direct response. -28.71. In the year 1999, what is the difference between the Area (% of total land area) of Terrestrial protected areas and Area (% of total land area) of Arable land?
Offer a very short reply. -2.53. In the year 1999, what is the difference between the Area (% of total land area) of Terrestrial protected areas and Area (% of total land area) of Permanent crop land?
Give a very brief answer. 9.09. In the year 1999, what is the difference between the Area (% of total land area) in Agricultural land and Area (% of total land area) in Arable land?
Give a very brief answer. 26.18. In the year 1999, what is the difference between the Area (% of total land area) of Agricultural land and Area (% of total land area) of Permanent crop land?
Make the answer very short. 37.8. In the year 1999, what is the difference between the Area (% of total land area) in Arable land and Area (% of total land area) in Permanent crop land?
Your answer should be very brief. 11.63. What is the ratio of the Area (% of total land area) in Terrestrial protected areas in 1993 to that in 1994?
Your response must be concise. 0.99. What is the ratio of the Area (% of total land area) in Agricultural land in 1993 to that in 1994?
Your response must be concise. 1. What is the ratio of the Area (% of total land area) of Arable land in 1993 to that in 1994?
Keep it short and to the point. 1. What is the ratio of the Area (% of total land area) of Permanent crop land in 1993 to that in 1994?
Your answer should be very brief. 1.03. What is the ratio of the Area (% of total land area) in Terrestrial protected areas in 1993 to that in 1995?
Your answer should be compact. 0.98. What is the ratio of the Area (% of total land area) in Agricultural land in 1993 to that in 1995?
Provide a succinct answer. 1. What is the ratio of the Area (% of total land area) in Permanent crop land in 1993 to that in 1995?
Offer a terse response. 1.07. What is the ratio of the Area (% of total land area) in Terrestrial protected areas in 1993 to that in 1996?
Make the answer very short. 0.96. What is the ratio of the Area (% of total land area) in Agricultural land in 1993 to that in 1996?
Offer a terse response. 1. What is the ratio of the Area (% of total land area) of Permanent crop land in 1993 to that in 1996?
Offer a terse response. 1.04. What is the ratio of the Area (% of total land area) of Terrestrial protected areas in 1993 to that in 1997?
Your answer should be compact. 0.96. What is the ratio of the Area (% of total land area) in Agricultural land in 1993 to that in 1997?
Ensure brevity in your answer.  1. What is the ratio of the Area (% of total land area) in Arable land in 1993 to that in 1997?
Keep it short and to the point. 0.98. What is the ratio of the Area (% of total land area) of Permanent crop land in 1993 to that in 1997?
Your answer should be compact. 1.01. What is the ratio of the Area (% of total land area) of Terrestrial protected areas in 1993 to that in 1998?
Your response must be concise. 0.94. What is the ratio of the Area (% of total land area) of Agricultural land in 1993 to that in 1998?
Offer a very short reply. 1. What is the ratio of the Area (% of total land area) of Arable land in 1993 to that in 1998?
Your answer should be very brief. 0.96. What is the ratio of the Area (% of total land area) of Terrestrial protected areas in 1993 to that in 1999?
Your response must be concise. 0.93. What is the ratio of the Area (% of total land area) of Permanent crop land in 1993 to that in 1999?
Offer a very short reply. 0.96. What is the ratio of the Area (% of total land area) in Terrestrial protected areas in 1994 to that in 1995?
Offer a terse response. 0.98. What is the ratio of the Area (% of total land area) in Agricultural land in 1994 to that in 1995?
Offer a very short reply. 1. What is the ratio of the Area (% of total land area) of Arable land in 1994 to that in 1995?
Offer a terse response. 1. What is the ratio of the Area (% of total land area) in Permanent crop land in 1994 to that in 1995?
Make the answer very short. 1.03. What is the ratio of the Area (% of total land area) of Terrestrial protected areas in 1994 to that in 1996?
Offer a terse response. 0.97. What is the ratio of the Area (% of total land area) in Permanent crop land in 1994 to that in 1996?
Offer a terse response. 1. What is the ratio of the Area (% of total land area) of Terrestrial protected areas in 1994 to that in 1997?
Give a very brief answer. 0.96. What is the ratio of the Area (% of total land area) in Agricultural land in 1994 to that in 1997?
Keep it short and to the point. 1. What is the ratio of the Area (% of total land area) of Arable land in 1994 to that in 1997?
Offer a terse response. 0.98. What is the ratio of the Area (% of total land area) in Permanent crop land in 1994 to that in 1997?
Your answer should be very brief. 0.98. What is the ratio of the Area (% of total land area) of Terrestrial protected areas in 1994 to that in 1998?
Your answer should be compact. 0.95. What is the ratio of the Area (% of total land area) of Agricultural land in 1994 to that in 1998?
Ensure brevity in your answer.  1. What is the ratio of the Area (% of total land area) of Arable land in 1994 to that in 1998?
Offer a very short reply. 0.96. What is the ratio of the Area (% of total land area) of Permanent crop land in 1994 to that in 1998?
Offer a very short reply. 0.96. What is the ratio of the Area (% of total land area) in Terrestrial protected areas in 1994 to that in 1999?
Your answer should be compact. 0.94. What is the ratio of the Area (% of total land area) of Agricultural land in 1994 to that in 1999?
Your answer should be compact. 1. What is the ratio of the Area (% of total land area) in Arable land in 1994 to that in 1999?
Give a very brief answer. 0.97. What is the ratio of the Area (% of total land area) in Permanent crop land in 1994 to that in 1999?
Offer a very short reply. 0.92. What is the ratio of the Area (% of total land area) in Terrestrial protected areas in 1995 to that in 1996?
Give a very brief answer. 0.99. What is the ratio of the Area (% of total land area) in Agricultural land in 1995 to that in 1996?
Provide a short and direct response. 1. What is the ratio of the Area (% of total land area) in Permanent crop land in 1995 to that in 1996?
Provide a short and direct response. 0.97. What is the ratio of the Area (% of total land area) in Terrestrial protected areas in 1995 to that in 1997?
Ensure brevity in your answer.  0.98. What is the ratio of the Area (% of total land area) in Agricultural land in 1995 to that in 1997?
Keep it short and to the point. 1. What is the ratio of the Area (% of total land area) in Arable land in 1995 to that in 1997?
Provide a succinct answer. 0.99. What is the ratio of the Area (% of total land area) of Permanent crop land in 1995 to that in 1997?
Offer a terse response. 0.95. What is the ratio of the Area (% of total land area) in Terrestrial protected areas in 1995 to that in 1998?
Your answer should be very brief. 0.96. What is the ratio of the Area (% of total land area) in Arable land in 1995 to that in 1998?
Provide a short and direct response. 0.97. What is the ratio of the Area (% of total land area) in Permanent crop land in 1995 to that in 1998?
Keep it short and to the point. 0.92. What is the ratio of the Area (% of total land area) of Terrestrial protected areas in 1995 to that in 1999?
Make the answer very short. 0.96. What is the ratio of the Area (% of total land area) of Arable land in 1995 to that in 1999?
Make the answer very short. 0.97. What is the ratio of the Area (% of total land area) of Permanent crop land in 1995 to that in 1999?
Offer a terse response. 0.89. What is the ratio of the Area (% of total land area) of Terrestrial protected areas in 1996 to that in 1997?
Your answer should be very brief. 0.99. What is the ratio of the Area (% of total land area) in Agricultural land in 1996 to that in 1997?
Your answer should be very brief. 1. What is the ratio of the Area (% of total land area) of Arable land in 1996 to that in 1997?
Provide a short and direct response. 0.98. What is the ratio of the Area (% of total land area) of Permanent crop land in 1996 to that in 1997?
Provide a succinct answer. 0.98. What is the ratio of the Area (% of total land area) in Terrestrial protected areas in 1996 to that in 1998?
Your answer should be very brief. 0.97. What is the ratio of the Area (% of total land area) of Permanent crop land in 1996 to that in 1998?
Your answer should be very brief. 0.95. What is the ratio of the Area (% of total land area) in Terrestrial protected areas in 1996 to that in 1999?
Provide a succinct answer. 0.97. What is the ratio of the Area (% of total land area) in Arable land in 1996 to that in 1999?
Make the answer very short. 0.97. What is the ratio of the Area (% of total land area) of Permanent crop land in 1996 to that in 1999?
Provide a short and direct response. 0.92. What is the ratio of the Area (% of total land area) in Terrestrial protected areas in 1997 to that in 1998?
Your response must be concise. 0.98. What is the ratio of the Area (% of total land area) of Arable land in 1997 to that in 1998?
Make the answer very short. 0.98. What is the ratio of the Area (% of total land area) in Permanent crop land in 1997 to that in 1998?
Your answer should be very brief. 0.97. What is the ratio of the Area (% of total land area) of Terrestrial protected areas in 1997 to that in 1999?
Keep it short and to the point. 0.97. What is the ratio of the Area (% of total land area) of Agricultural land in 1997 to that in 1999?
Provide a short and direct response. 1. What is the ratio of the Area (% of total land area) of Permanent crop land in 1997 to that in 1999?
Your answer should be very brief. 0.94. What is the ratio of the Area (% of total land area) of Agricultural land in 1998 to that in 1999?
Your answer should be very brief. 1. What is the ratio of the Area (% of total land area) in Permanent crop land in 1998 to that in 1999?
Provide a short and direct response. 0.97. What is the difference between the highest and the second highest Area (% of total land area) of Terrestrial protected areas?
Your answer should be compact. 0.08. What is the difference between the highest and the second highest Area (% of total land area) of Agricultural land?
Provide a succinct answer. 0.01. What is the difference between the highest and the second highest Area (% of total land area) in Arable land?
Give a very brief answer. 0.04. What is the difference between the highest and the second highest Area (% of total land area) of Permanent crop land?
Provide a succinct answer. 0.03. What is the difference between the highest and the lowest Area (% of total land area) of Terrestrial protected areas?
Your response must be concise. 0.67. What is the difference between the highest and the lowest Area (% of total land area) of Agricultural land?
Ensure brevity in your answer.  0.1. What is the difference between the highest and the lowest Area (% of total land area) of Arable land?
Keep it short and to the point. 0.46. What is the difference between the highest and the lowest Area (% of total land area) in Permanent crop land?
Give a very brief answer. 0.09. 